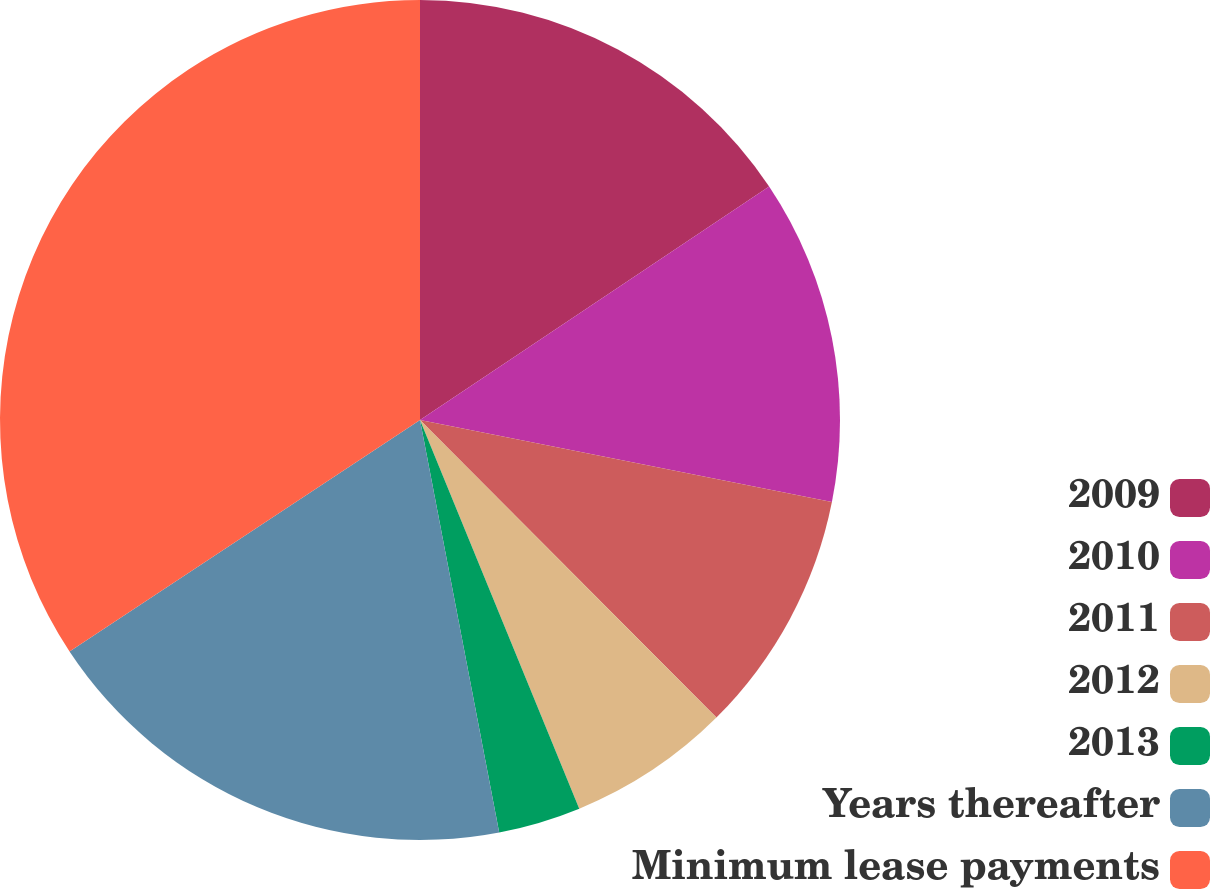Convert chart. <chart><loc_0><loc_0><loc_500><loc_500><pie_chart><fcel>2009<fcel>2010<fcel>2011<fcel>2012<fcel>2013<fcel>Years thereafter<fcel>Minimum lease payments<nl><fcel>15.62%<fcel>12.51%<fcel>9.4%<fcel>6.28%<fcel>3.17%<fcel>18.73%<fcel>34.29%<nl></chart> 